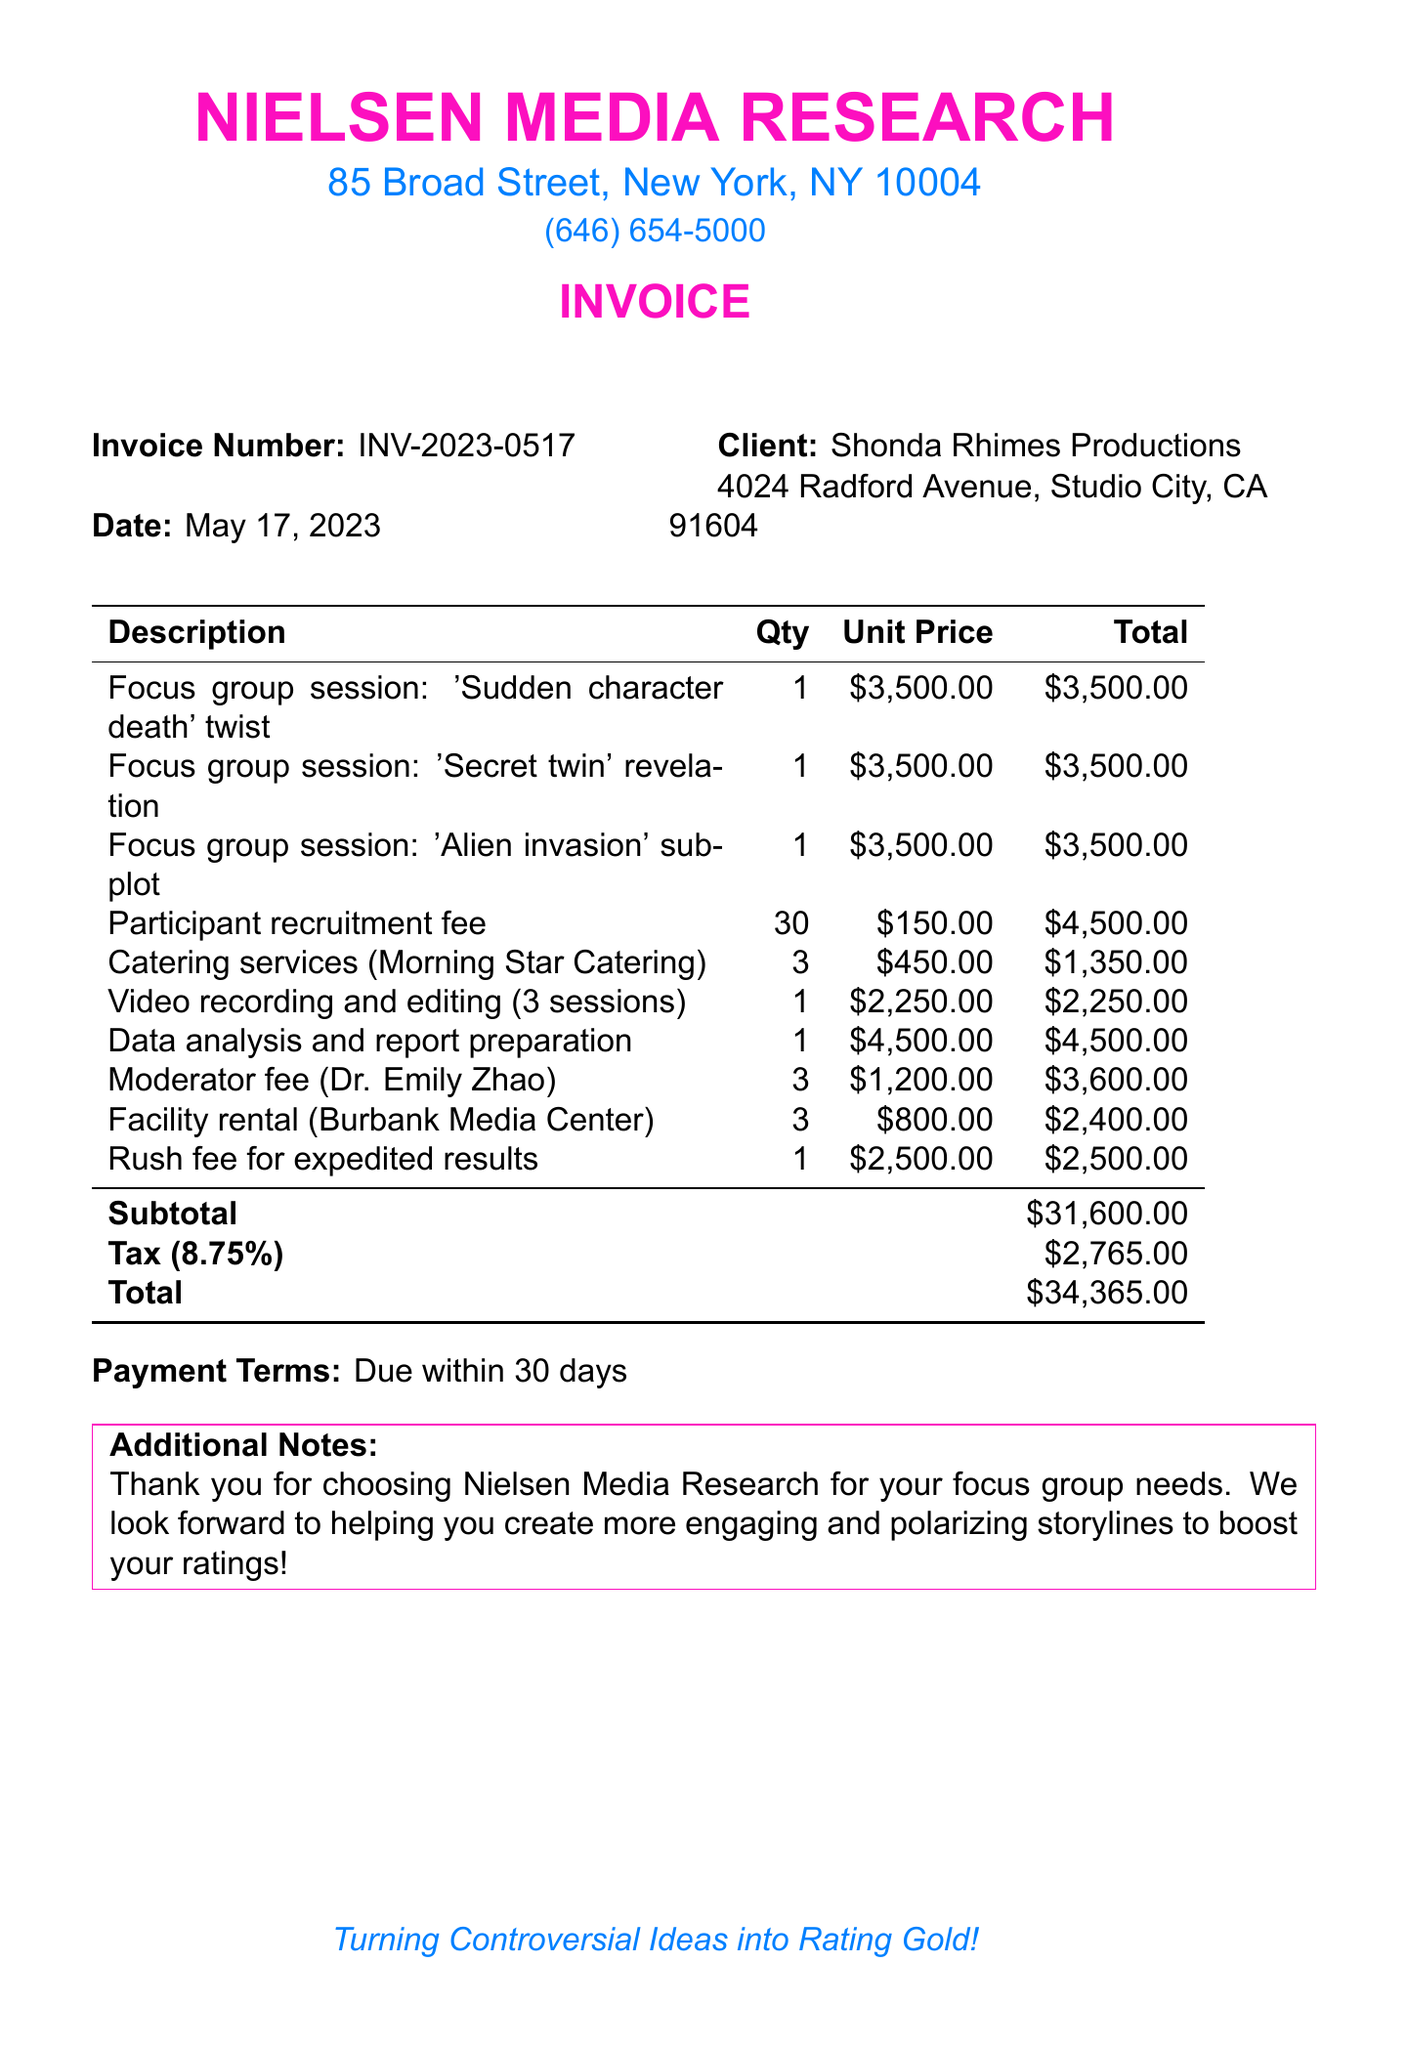What is the company name? The company name is located at the top of the document under the header.
Answer: Nielsen Media Research What is the invoice number? The invoice number is listed further down the document and is used for tracking purposes.
Answer: INV-2023-0517 What is the total amount due? The total amount is calculated at the end of the invoice, including tax.
Answer: $34,365.00 How many focus group sessions were conducted? The focus group session items are listed individually, and their quantities are noted.
Answer: 3 What is the participant recruitment fee total? The participant recruitment fee is detailed in the list of items, showing totals and unit prices.
Answer: $4,500.00 Who is the moderator for the sessions? The moderator's name is provided next to the fee for their services.
Answer: Dr. Emily Zhao What percentage is the tax rate applied? The tax rate is shown alongside the subtotal and total calculations in the invoice.
Answer: 8.75% How many catering services sessions were invoiced? The number of catering sessions required is indicated next to the service description.
Answer: 3 What are the payment terms? The payment terms are stated towards the end of the invoice for clarity on due dates.
Answer: Due within 30 days What is the additional note provided in the invoice? The additional note is a thank you message and further encouragement to the client.
Answer: Thank you for choosing Nielsen Media Research for your focus group needs 